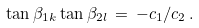<formula> <loc_0><loc_0><loc_500><loc_500>\tan \beta _ { 1 k } \tan \beta _ { 2 l } \, = \, - c _ { 1 } / c _ { 2 } \, .</formula> 